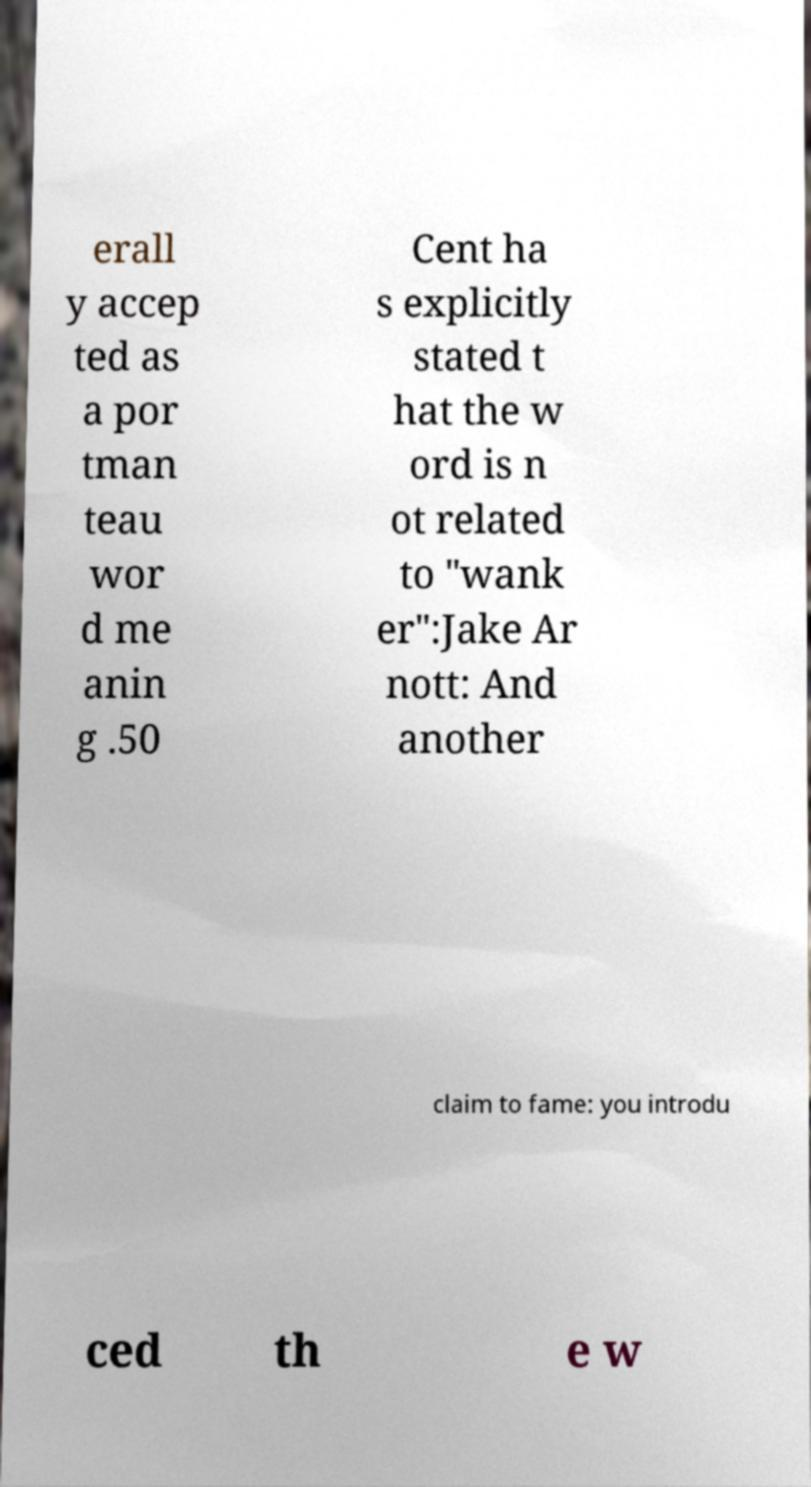Could you extract and type out the text from this image? erall y accep ted as a por tman teau wor d me anin g .50 Cent ha s explicitly stated t hat the w ord is n ot related to "wank er":Jake Ar nott: And another claim to fame: you introdu ced th e w 